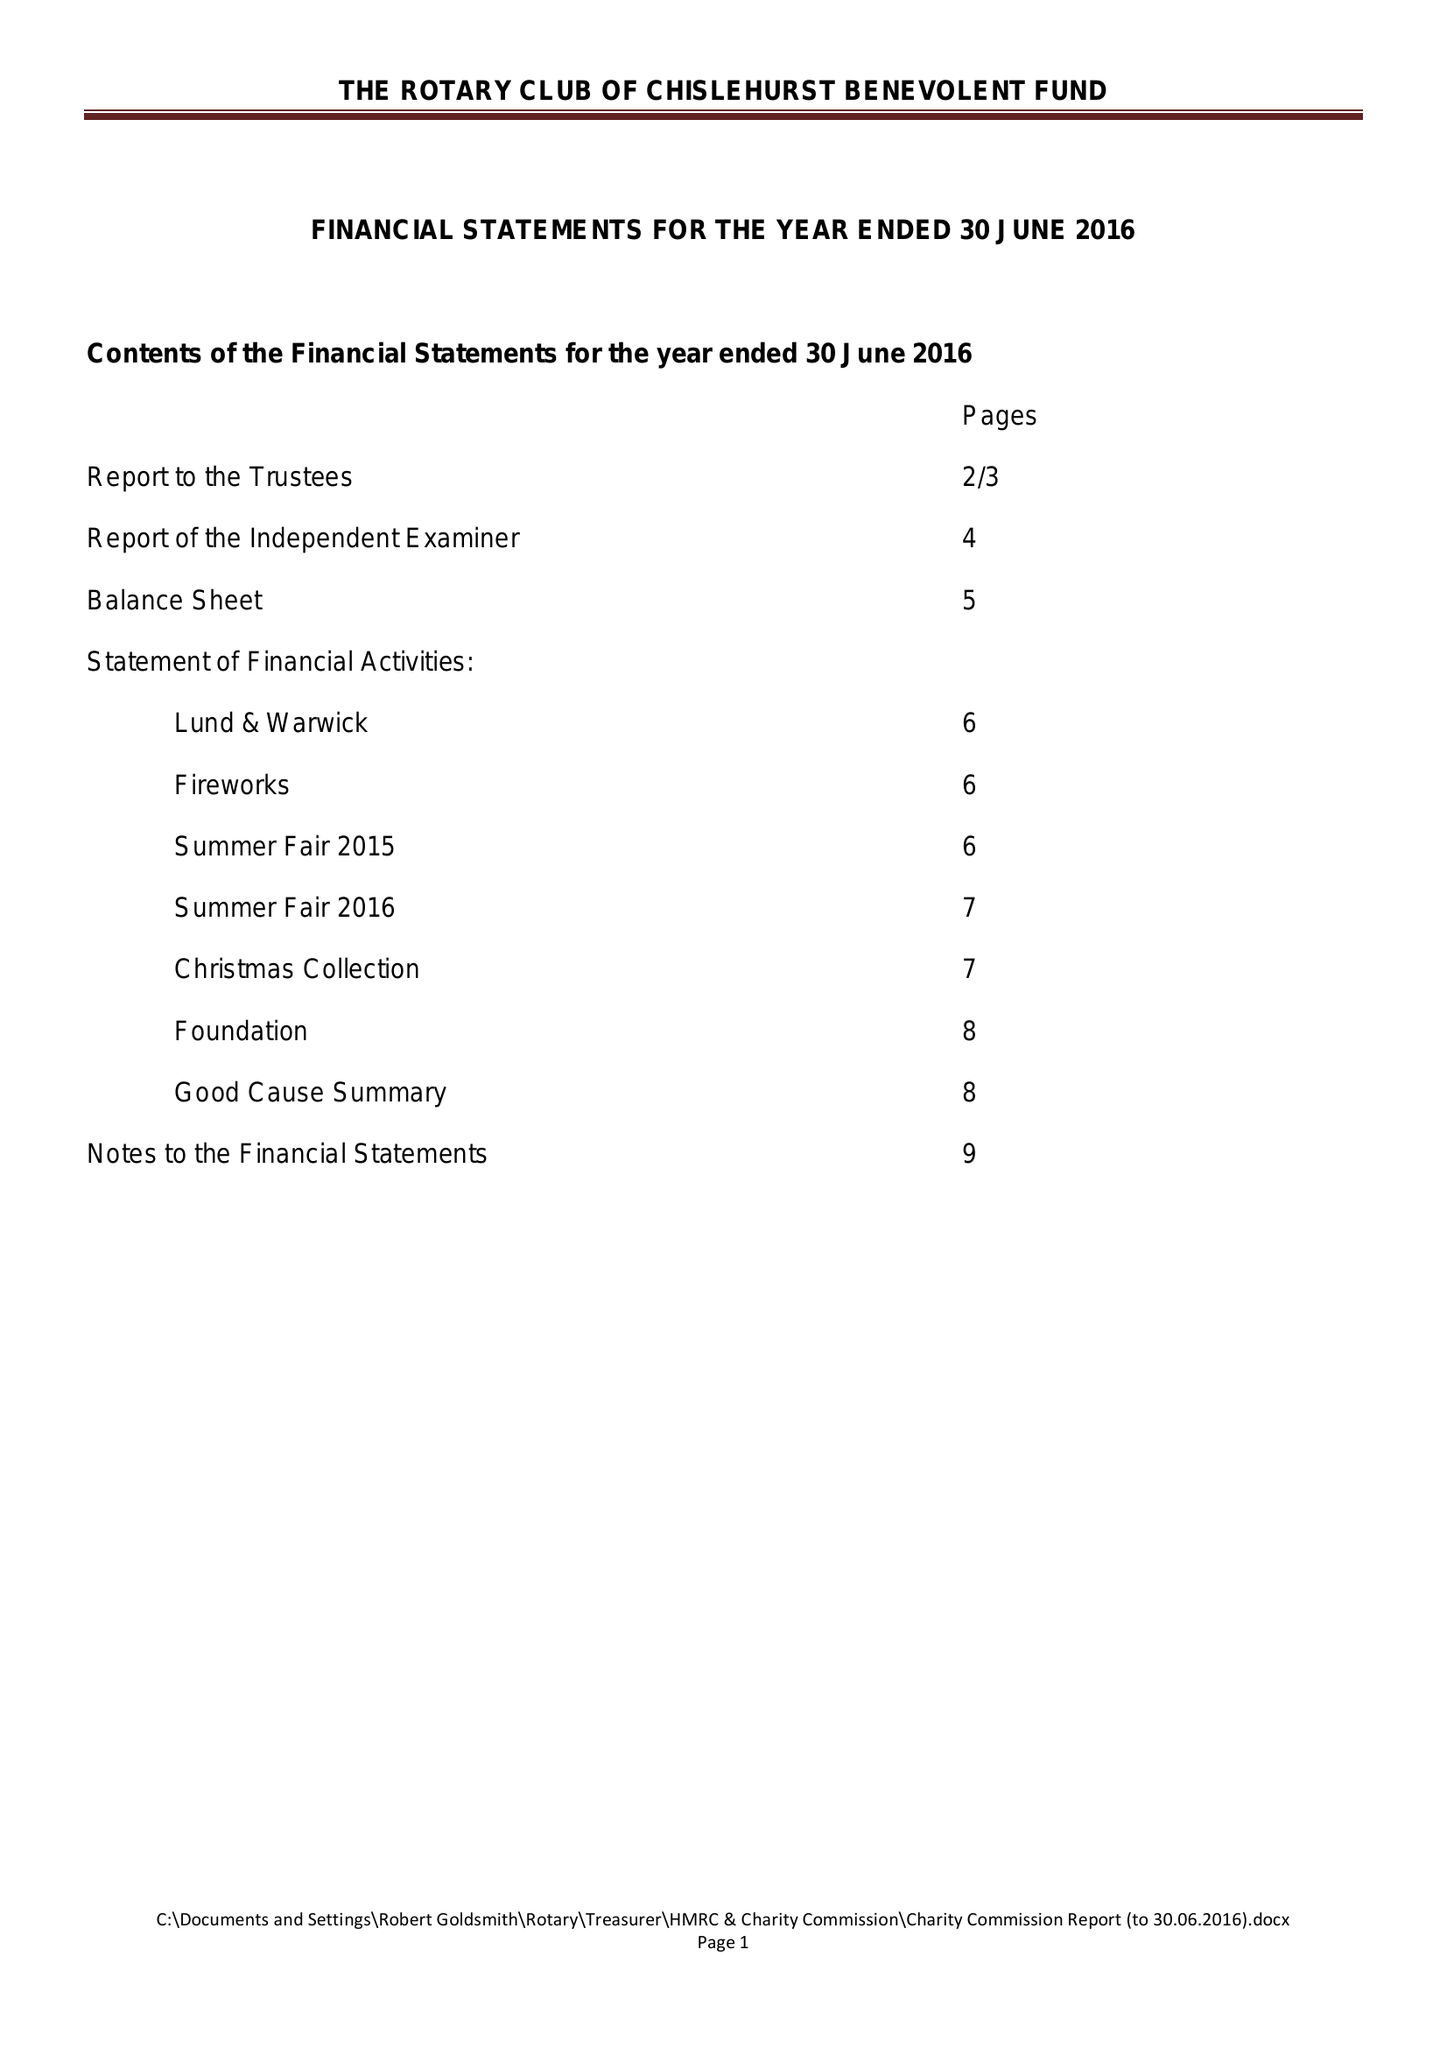What is the value for the report_date?
Answer the question using a single word or phrase. 2016-06-30 